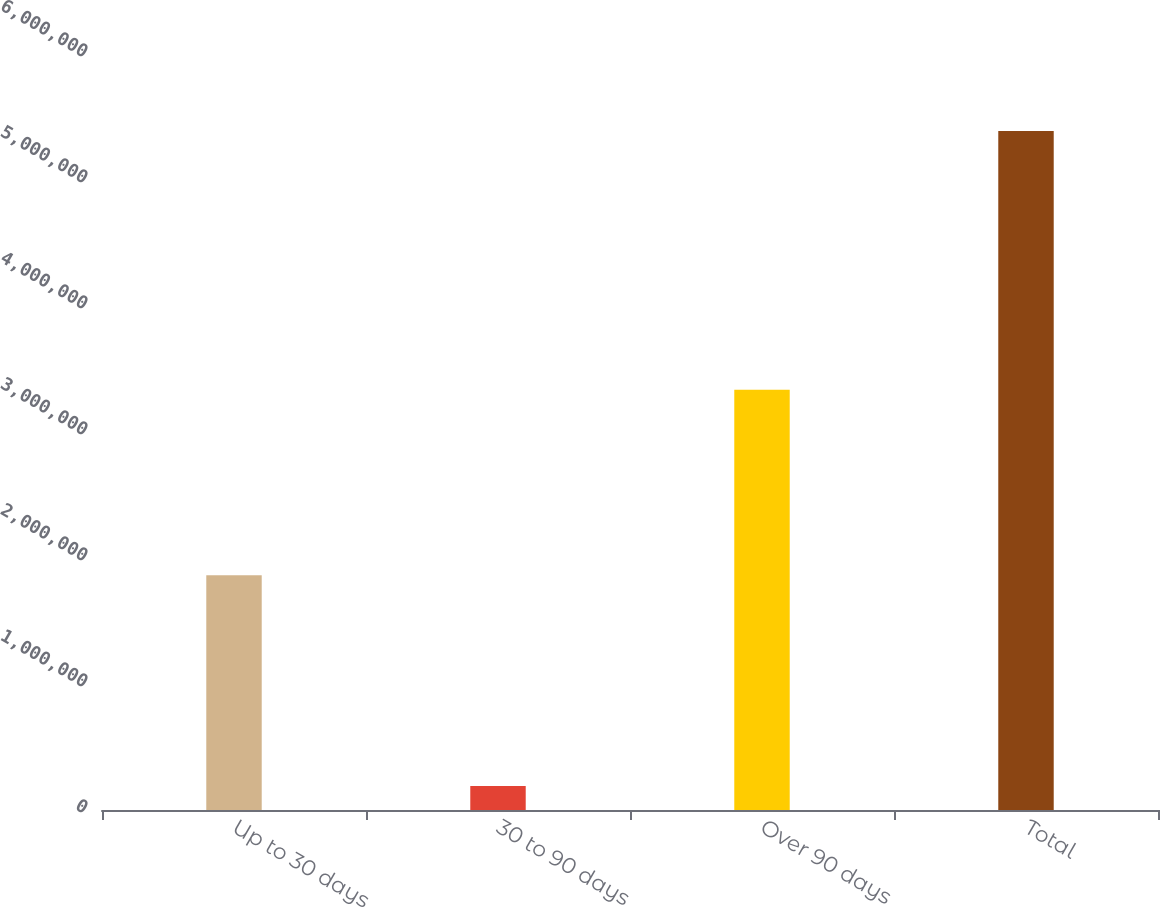Convert chart to OTSL. <chart><loc_0><loc_0><loc_500><loc_500><bar_chart><fcel>Up to 30 days<fcel>30 to 90 days<fcel>Over 90 days<fcel>Total<nl><fcel>1.86381e+06<fcel>190203<fcel>3.33573e+06<fcel>5.38974e+06<nl></chart> 